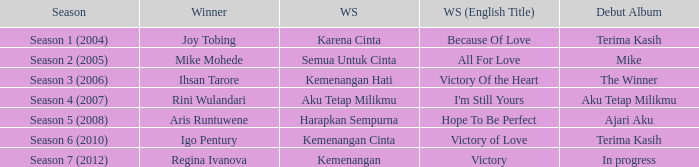Parse the table in full. {'header': ['Season', 'Winner', 'WS', 'WS (English Title)', 'Debut Album'], 'rows': [['Season 1 (2004)', 'Joy Tobing', 'Karena Cinta', 'Because Of Love', 'Terima Kasih'], ['Season 2 (2005)', 'Mike Mohede', 'Semua Untuk Cinta', 'All For Love', 'Mike'], ['Season 3 (2006)', 'Ihsan Tarore', 'Kemenangan Hati', 'Victory Of the Heart', 'The Winner'], ['Season 4 (2007)', 'Rini Wulandari', 'Aku Tetap Milikmu', "I'm Still Yours", 'Aku Tetap Milikmu'], ['Season 5 (2008)', 'Aris Runtuwene', 'Harapkan Sempurna', 'Hope To Be Perfect', 'Ajari Aku'], ['Season 6 (2010)', 'Igo Pentury', 'Kemenangan Cinta', 'Victory of Love', 'Terima Kasih'], ['Season 7 (2012)', 'Regina Ivanova', 'Kemenangan', 'Victory', 'In progress']]} Who won with the song kemenangan cinta? Igo Pentury. 